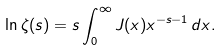Convert formula to latex. <formula><loc_0><loc_0><loc_500><loc_500>\ln \zeta ( s ) = s \int _ { 0 } ^ { \infty } J ( x ) x ^ { - s - 1 } \, d x .</formula> 